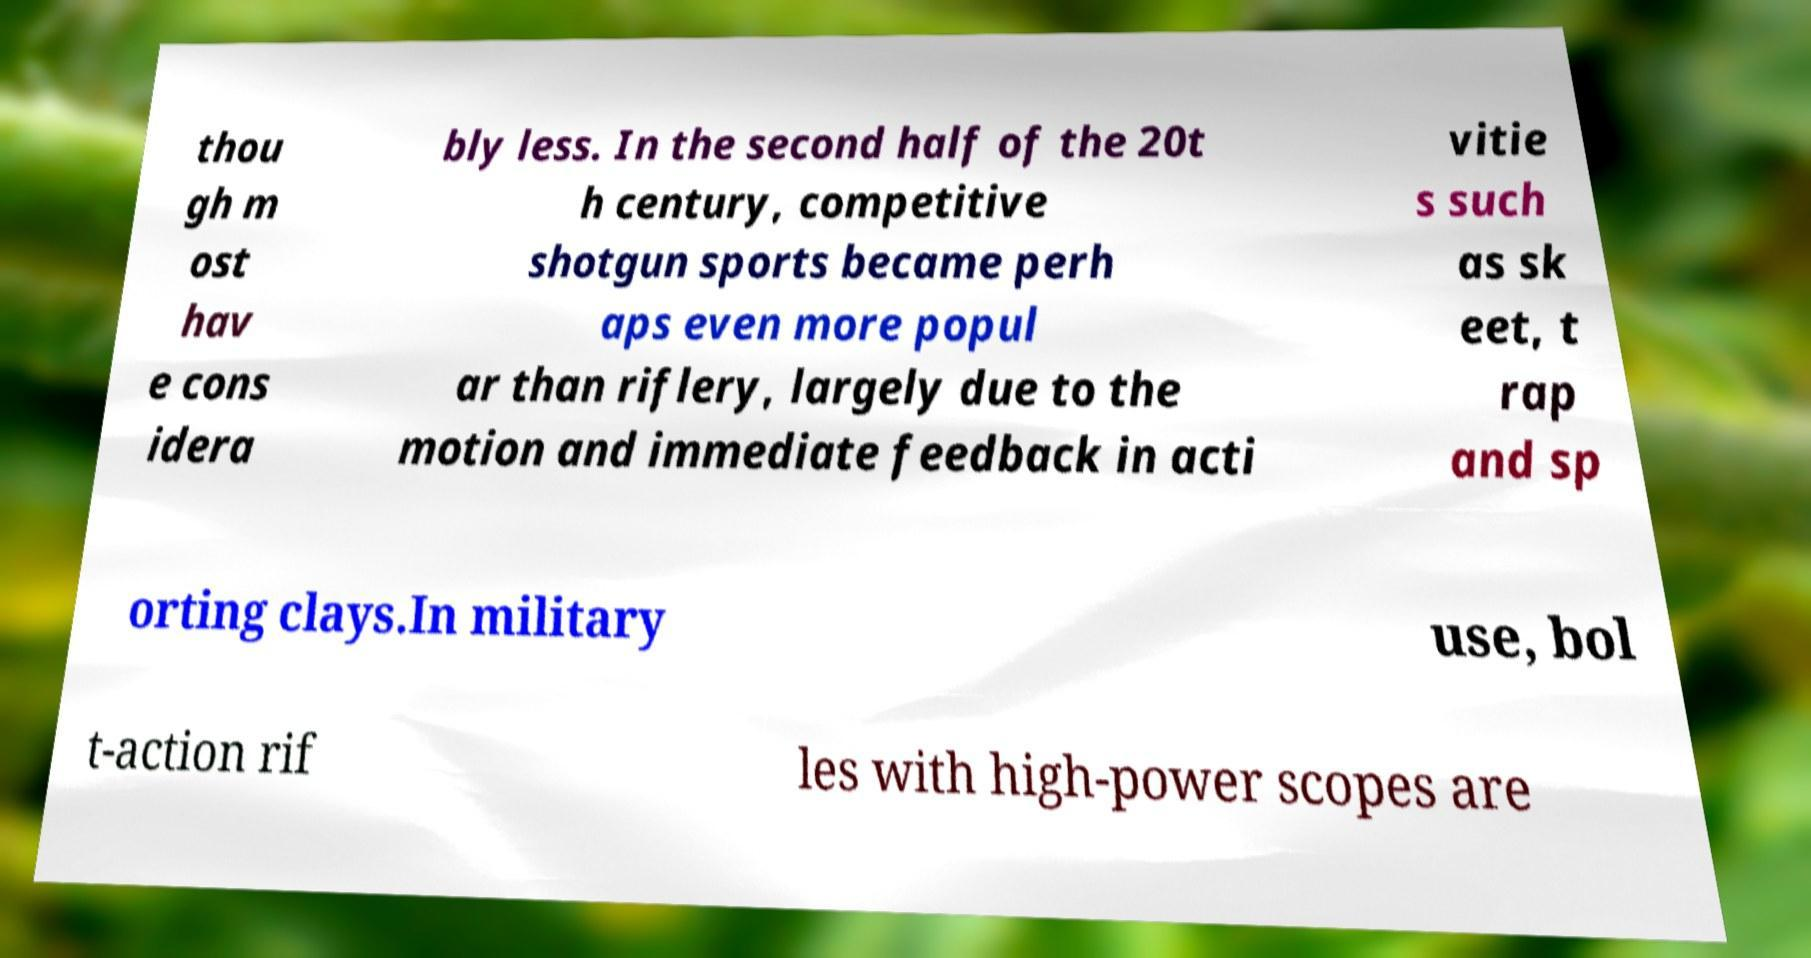I need the written content from this picture converted into text. Can you do that? thou gh m ost hav e cons idera bly less. In the second half of the 20t h century, competitive shotgun sports became perh aps even more popul ar than riflery, largely due to the motion and immediate feedback in acti vitie s such as sk eet, t rap and sp orting clays.In military use, bol t-action rif les with high-power scopes are 